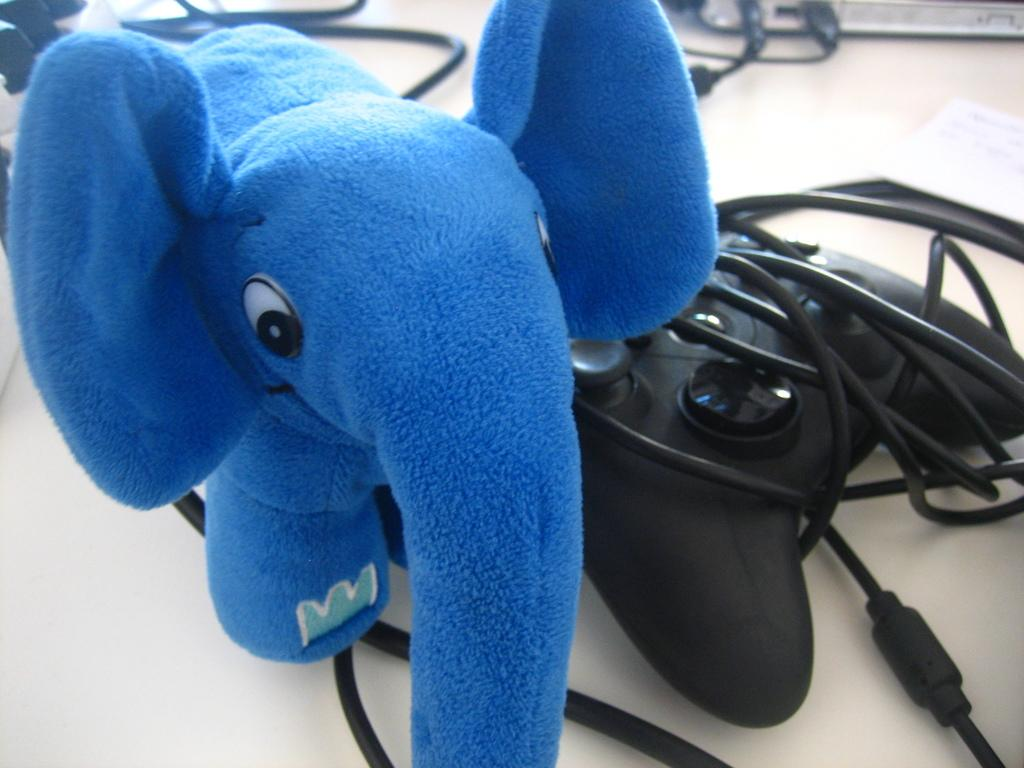What is the main subject in the center of the image? There is a toy elephant in the center of the image. What can be seen near the toy elephant? There is a joystick in the image. What else is present on the table in the image? Cables are present in the image. Can you describe any other items on the table in the image? There are other items on the table in the image. What type of trade is happening in the image? There is no trade happening in the image; it features a toy elephant, a joystick, cables, and other items on the table. --- Facts: 1. There is a person in the image. 2. The person is wearing a hat. 3. The person is holding a book. 4. There is a table in the image. 5. The table has a lamp on it. Absurd Topics: unicorn, rainbow, treasure Conversation: Who or what is the main subject in the image? There is a person in the image. What can be seen on the person's head in the image? The person is wearing a hat. What is the person holding in the image? The person is holding a book. What can be seen on the table in the image? There is a table in the image, and it has a lamp on it. Reasoning: Let's think step by step in order to produce the conversation. We start by identifying the main subject in the image, which is the person. Next, we describe the person's attire, which in this case is a hat. Then, we mention the object that the person is holding, which is a book. Finally, we describe the object that is on the table in the image, which is a lamp. Absurd Question/Answer: Can you see a unicorn in the image? There is no unicorn present in the image. --- Facts: 1. There is a group of people in the image. 2. The people are wearing matching shirts. 3. The people are holding hands. 4. There is a banner in the background of the image. Absurd Topics: parrot, piano, performance Conversation: How many people are in the image? There is a group of people in the image. What can be seen on the people's shirts in the image? The people are wearing matching shirts. What are the people doing in the image? The people are holding hands. What can be seen in the background of the image? There is a banner in the background of the image. Reasoning: Let's think step by step in order to produce the conversation. We start by identifying the main subject in the image, which is the group of people. Next, we describe the people's attire, 